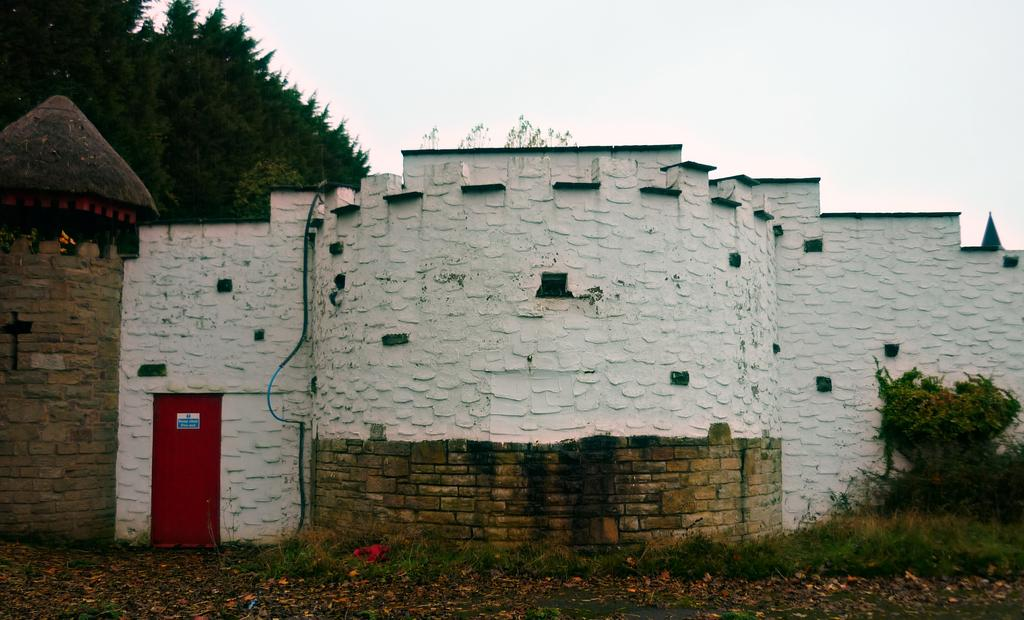What type of structure is present in the picture? There is a building in the picture. Can you describe a specific feature of the building? There is a red color door on the building. What type of vegetation can be seen in the picture? There is grass, plants, and trees visible in the picture. What part of the natural environment is visible in the picture? The sky is visible in the picture. How many men are interacting with the police in the picture? There are no men or police present in the picture; it only features a building, grass, plants, trees, and the sky. 